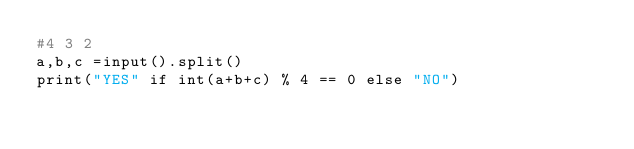<code> <loc_0><loc_0><loc_500><loc_500><_Python_>#4 3 2
a,b,c =input().split()
print("YES" if int(a+b+c) % 4 == 0 else "NO")</code> 